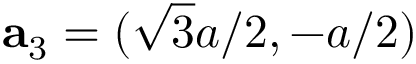Convert formula to latex. <formula><loc_0><loc_0><loc_500><loc_500>a _ { 3 } = ( \sqrt { 3 } a / 2 , - a / 2 )</formula> 